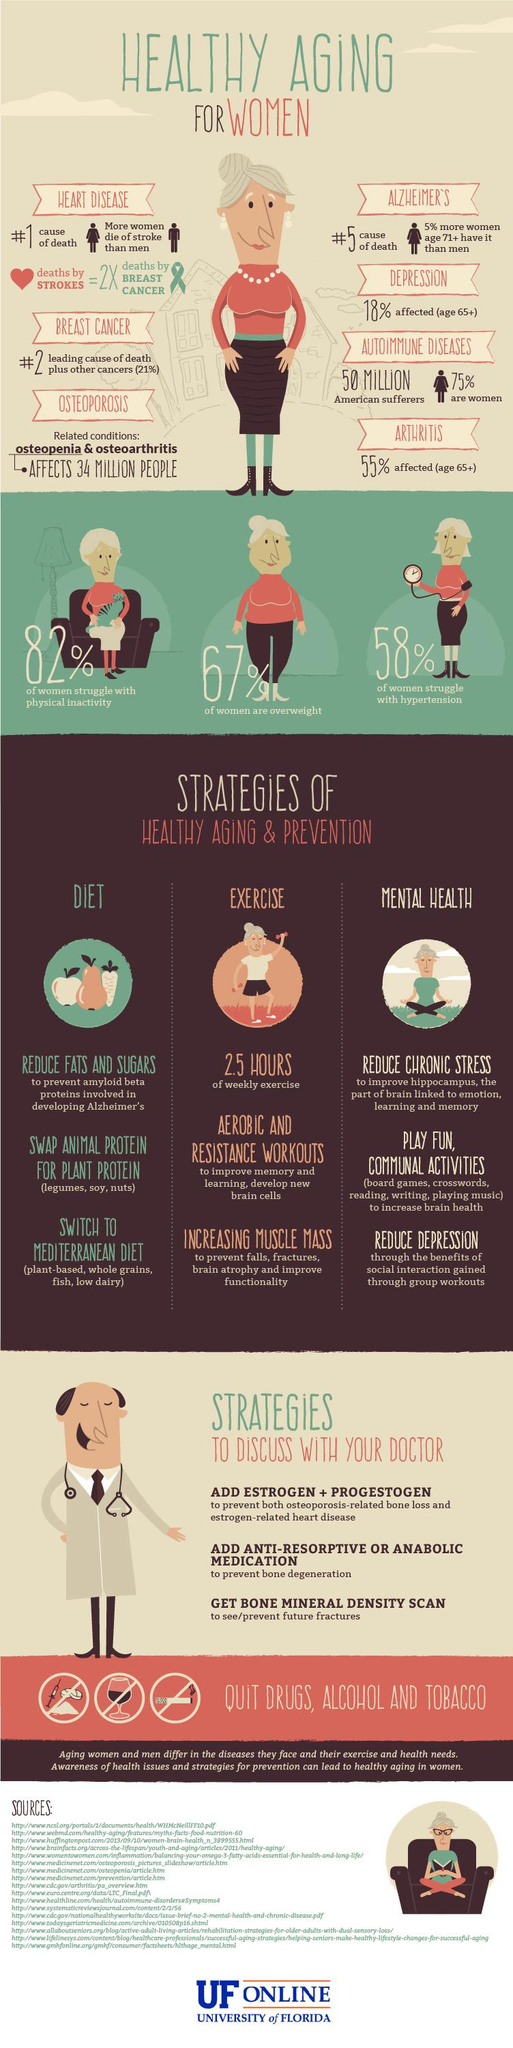Identify some key points in this picture. According to statistics, women over the age of 71 are more likely to be affected by Alzheimer's disease than men. In particular, this condition is seen in 5% more women than men in this age group. Aerobic and resistance workouts have been shown to improve memory and develop new brain cells. According to the data, 67% of the women are overweight. According to a recent survey, 58% of women have struggled with high blood pressure. According to the recommended guidelines, the average individual should aim to engage in physical activity for a minimum of 2.5 hours per week. 